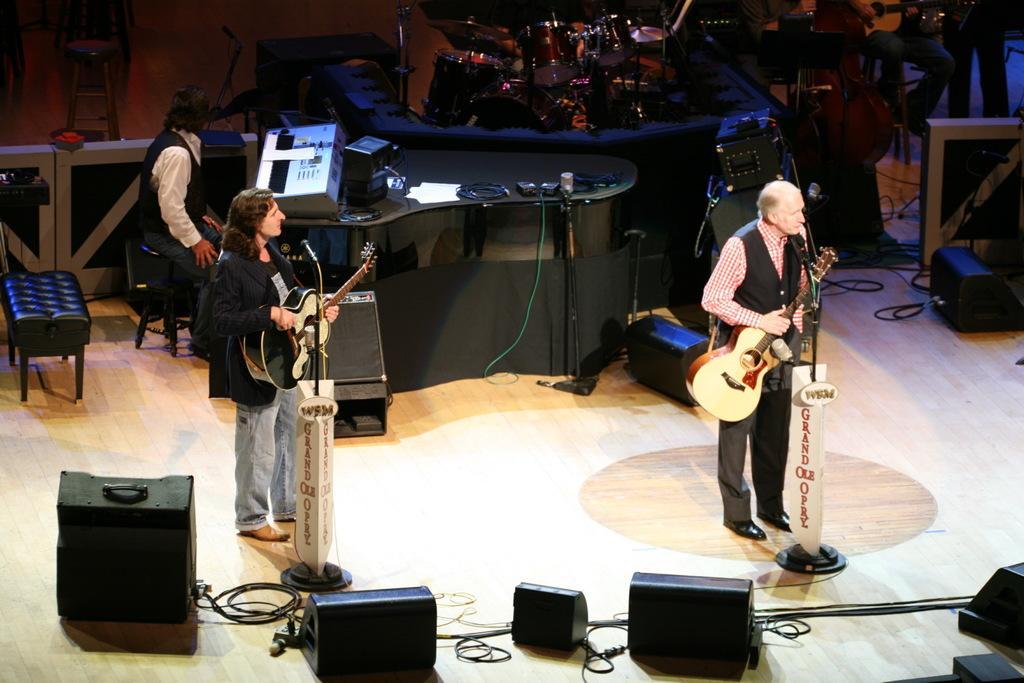Could you give a brief overview of what you see in this image? These two persons are playing guitar in-front of mic. This person is sitting in-front of this table. On this table there is a device and cables. On floor there are devices and cables. Far these are musical instruments. 